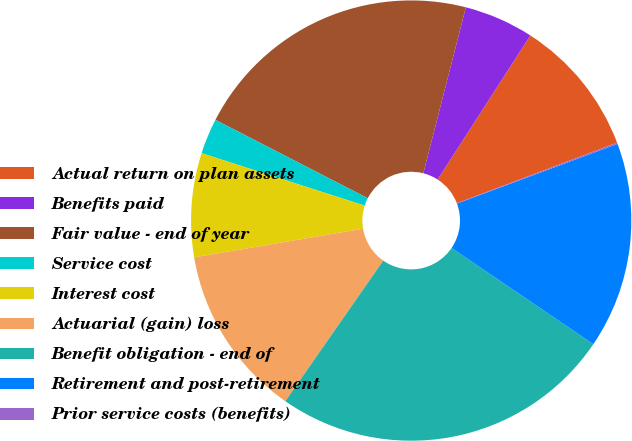<chart> <loc_0><loc_0><loc_500><loc_500><pie_chart><fcel>Actual return on plan assets<fcel>Benefits paid<fcel>Fair value - end of year<fcel>Service cost<fcel>Interest cost<fcel>Actuarial (gain) loss<fcel>Benefit obligation - end of<fcel>Retirement and post-retirement<fcel>Prior service costs (benefits)<nl><fcel>10.13%<fcel>5.11%<fcel>21.43%<fcel>2.61%<fcel>7.62%<fcel>12.64%<fcel>25.19%<fcel>15.15%<fcel>0.1%<nl></chart> 